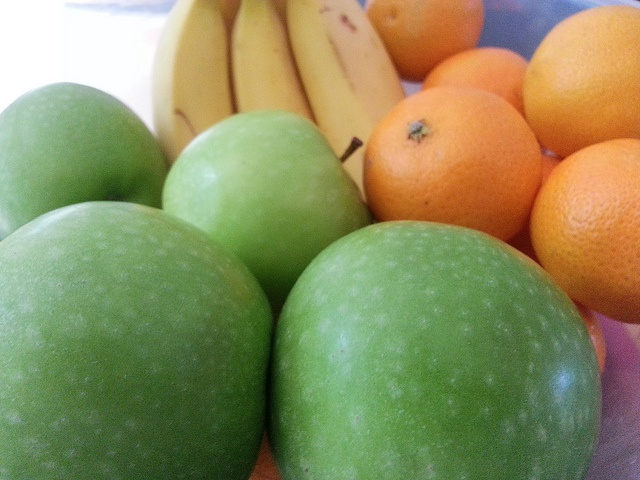Describe the objects in this image and their specific colors. I can see apple in white, green, darkgreen, and lightgreen tones, apple in white, green, darkgreen, and lightgreen tones, apple in white, olive, lightgreen, and darkgreen tones, orange in white, orange, red, brown, and maroon tones, and banana in white, tan, and olive tones in this image. 